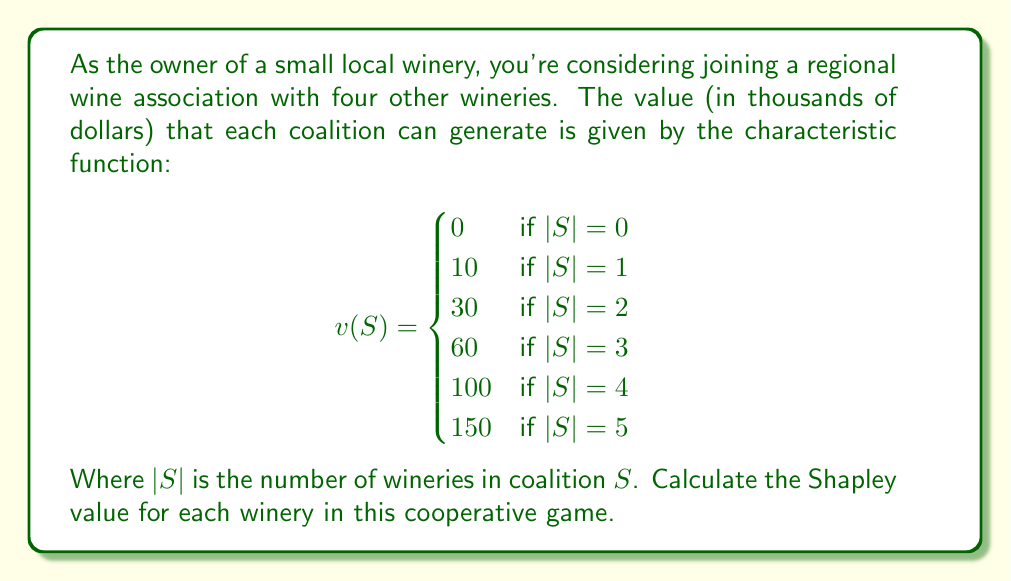Show me your answer to this math problem. To solve this problem, we'll use the Shapley value formula:

$$\phi_i(v) = \sum_{S \subseteq N \setminus \{i\}} \frac{|S|!(n-|S|-1)!}{n!}[v(S \cup \{i\}) - v(S)]$$

Where:
- $N$ is the set of all players (wineries)
- $n = |N| = 5$ is the total number of players
- $S$ is a coalition not containing player $i$
- $v(S)$ is the characteristic function

Given the symmetry of the game (all players are identical), we only need to calculate the Shapley value for one player, as it will be the same for all.

Let's calculate the marginal contributions for each coalition size:

1. $|S| = 0$: $v(\{i\}) - v(\emptyset) = 10 - 0 = 10$
2. $|S| = 1$: $v(\{i,j\}) - v(\{j\}) = 30 - 10 = 20$
3. $|S| = 2$: $v(\{i,j,k\}) - v(\{j,k\}) = 60 - 30 = 30$
4. $|S| = 3$: $v(\{i,j,k,l\}) - v(\{j,k,l\}) = 100 - 60 = 40$
5. $|S| = 4$: $v(\{i,j,k,l,m\}) - v(\{j,k,l,m\}) = 150 - 100 = 50$

Now, let's apply the Shapley value formula:

$$\begin{align*}
\phi_i(v) &= \frac{0!(5-0-1)!}{5!} \cdot 10 + \frac{1!(5-1-1)!}{5!} \cdot 20 + \frac{2!(5-2-1)!}{5!} \cdot 30 \\
&+ \frac{3!(5-3-1)!}{5!} \cdot 40 + \frac{4!(5-4-1)!}{5!} \cdot 50 \\
&= \frac{1}{5} \cdot 10 + \frac{1}{10} \cdot 20 + \frac{1}{10} \cdot 30 + \frac{1}{10} \cdot 40 + \frac{1}{5} \cdot 50 \\
&= 2 + 2 + 3 + 4 + 10 \\
&= 21
\end{align*}$$

Therefore, the Shapley value for each winery is 21 thousand dollars.
Answer: The Shapley value for each winery in this cooperative game is $21,000. 